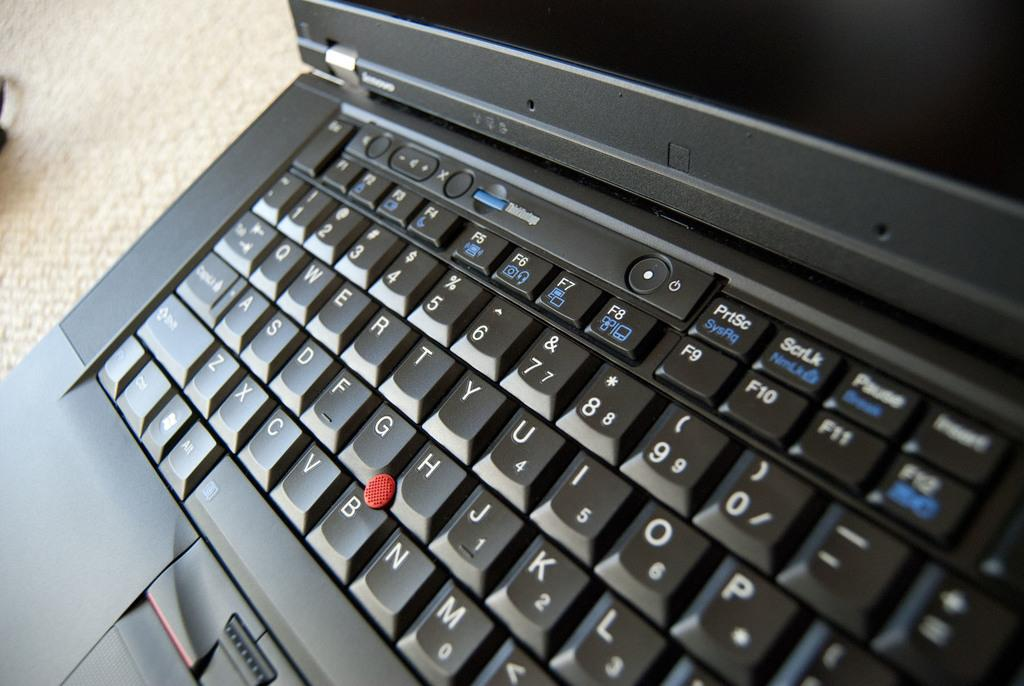Provide a one-sentence caption for the provided image. Black Lenovo laptop with a key that has PriSc in white and SysRq in blue. 